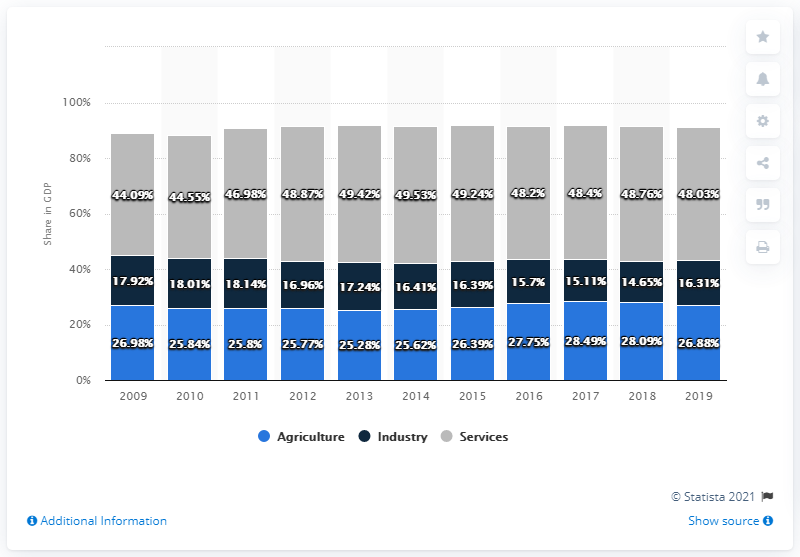List a handful of essential elements in this visual. The industry's average over the past three years is 15.36. In the chart, the starting year is 2009. 